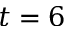Convert formula to latex. <formula><loc_0><loc_0><loc_500><loc_500>t = 6</formula> 